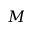Convert formula to latex. <formula><loc_0><loc_0><loc_500><loc_500>M</formula> 